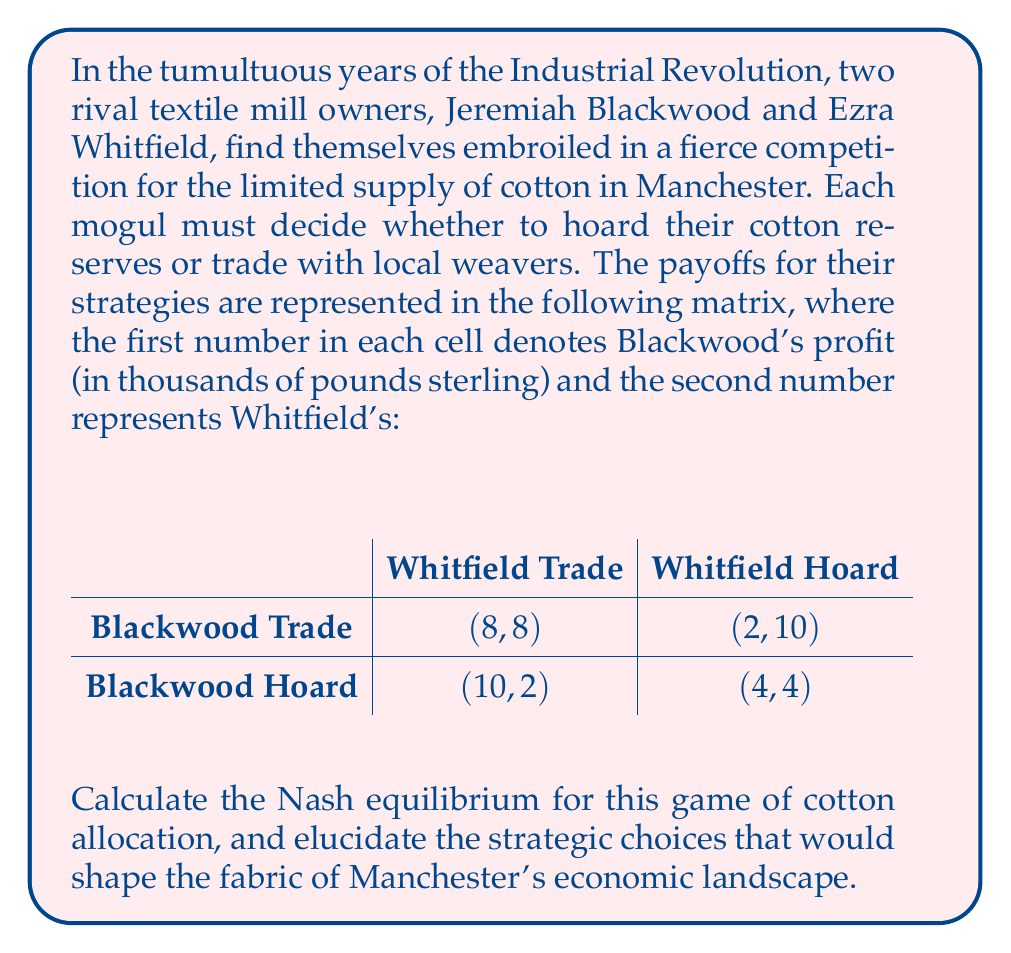Show me your answer to this math problem. To determine the Nash equilibrium in this game of cotton allocation during the Industrial Revolution, we must examine each player's best response to the other's strategy. A Nash equilibrium occurs when neither player can unilaterally improve their payoff by changing their strategy.

Let us commence with Jeremiah Blackwood's perspective:

1. If Ezra Whitfield chooses to trade:
   - Blackwood's payoff for trading: 8
   - Blackwood's payoff for hoarding: 10
   Blackwood's best response is to hoard.

2. If Whitfield chooses to hoard:
   - Blackwood's payoff for trading: 2
   - Blackwood's payoff for hoarding: 4
   Blackwood's best response is to hoard.

Now, let us consider Ezra Whitfield's perspective:

1. If Blackwood chooses to trade:
   - Whitfield's payoff for trading: 8
   - Whitfield's payoff for hoarding: 10
   Whitfield's best response is to hoard.

2. If Blackwood chooses to hoard:
   - Whitfield's payoff for trading: 2
   - Whitfield's payoff for hoarding: 4
   Whitfield's best response is to hoard.

Observing these best responses, we can deduce that regardless of what the other player does, both Blackwood and Whitfield will always choose to hoard their cotton reserves. This leads us to the Nash equilibrium of (Blackwood Hoard, Whitfield Hoard) with payoffs of (4, 4).

To verify this is indeed a Nash equilibrium:
- If Blackwood unilaterally changes to Trade, his payoff would decrease from 4 to 2.
- If Whitfield unilaterally changes to Trade, his payoff would decrease from 4 to 2.

Thus, neither player has an incentive to deviate from the strategy of hoarding, confirming that (Blackwood Hoard, Whitfield Hoard) is the Nash equilibrium of this game.
Answer: The Nash equilibrium for this game of cotton allocation during the Industrial Revolution is (Blackwood Hoard, Whitfield Hoard) with payoffs of (4, 4). 